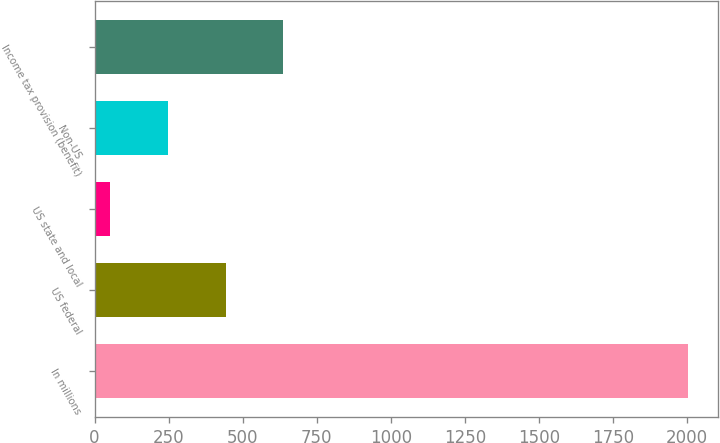<chart> <loc_0><loc_0><loc_500><loc_500><bar_chart><fcel>In millions<fcel>US federal<fcel>US state and local<fcel>Non-US<fcel>Income tax provision (benefit)<nl><fcel>2005<fcel>442.6<fcel>52<fcel>247.3<fcel>637.9<nl></chart> 